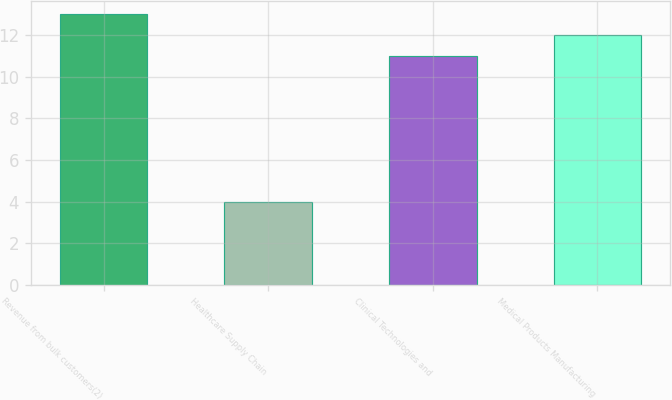<chart> <loc_0><loc_0><loc_500><loc_500><bar_chart><fcel>Revenue from bulk customers(2)<fcel>Healthcare Supply Chain<fcel>Clinical Technologies and<fcel>Medical Products Manufacturing<nl><fcel>13<fcel>4<fcel>11<fcel>12<nl></chart> 